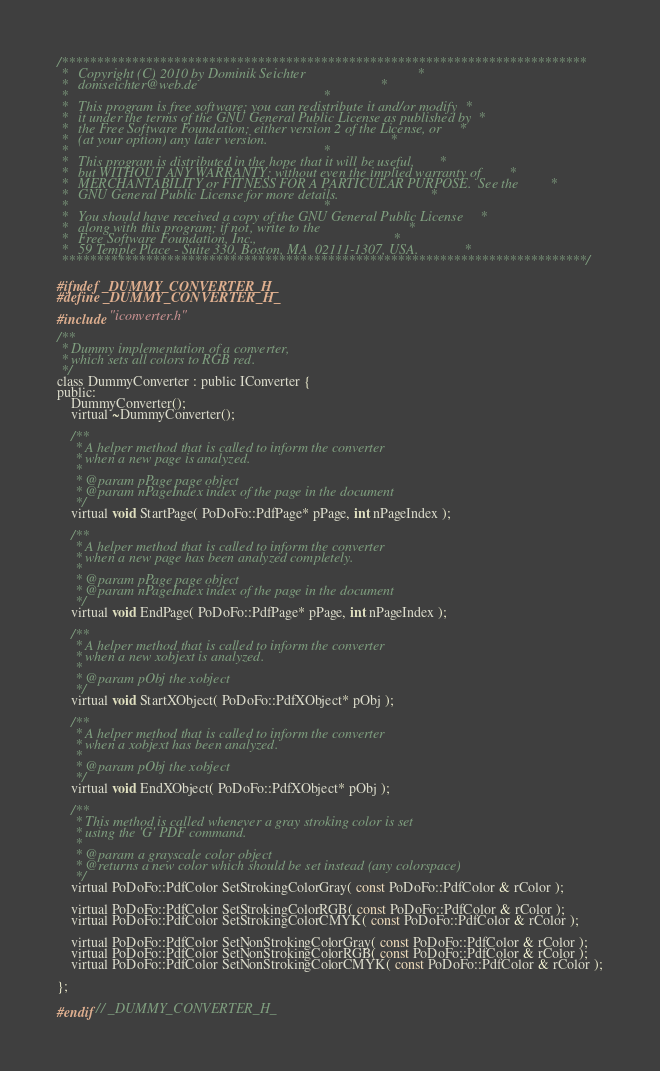<code> <loc_0><loc_0><loc_500><loc_500><_C_>/***************************************************************************
 *   Copyright (C) 2010 by Dominik Seichter                                *
 *   domseichter@web.de                                                    *
 *                                                                         *
 *   This program is free software; you can redistribute it and/or modify  *
 *   it under the terms of the GNU General Public License as published by  *
 *   the Free Software Foundation; either version 2 of the License, or     *
 *   (at your option) any later version.                                   *
 *                                                                         *
 *   This program is distributed in the hope that it will be useful,       *
 *   but WITHOUT ANY WARRANTY; without even the implied warranty of        *
 *   MERCHANTABILITY or FITNESS FOR A PARTICULAR PURPOSE.  See the         *
 *   GNU General Public License for more details.                          *
 *                                                                         *
 *   You should have received a copy of the GNU General Public License     *
 *   along with this program; if not, write to the                         *
 *   Free Software Foundation, Inc.,                                       *
 *   59 Temple Place - Suite 330, Boston, MA  02111-1307, USA.             *
 ***************************************************************************/

#ifndef _DUMMY_CONVERTER_H_
#define _DUMMY_CONVERTER_H_

#include "iconverter.h"

/**
 * Dummy implementation of a converter,
 * which sets all colors to RGB red.
 */
class DummyConverter : public IConverter {
public:
    DummyConverter();
    virtual ~DummyConverter();

    /**
     * A helper method that is called to inform the converter
     * when a new page is analyzed.
     * 
     * @param pPage page object
     * @param nPageIndex index of the page in the document
     */
    virtual void StartPage( PoDoFo::PdfPage* pPage, int nPageIndex );

    /**
     * A helper method that is called to inform the converter
     * when a new page has been analyzed completely.
     * 
     * @param pPage page object
     * @param nPageIndex index of the page in the document
     */
    virtual void EndPage( PoDoFo::PdfPage* pPage, int nPageIndex );

    /**
     * A helper method that is called to inform the converter
     * when a new xobjext is analyzed.
     * 
     * @param pObj the xobject
     */
    virtual void StartXObject( PoDoFo::PdfXObject* pObj );

    /**
     * A helper method that is called to inform the converter
     * when a xobjext has been analyzed.
     * 
     * @param pObj the xobject
     */
    virtual void EndXObject( PoDoFo::PdfXObject* pObj );

    /**
     * This method is called whenever a gray stroking color is set
     * using the 'G' PDF command.
     *
     * @param a grayscale color object
     * @returns a new color which should be set instead (any colorspace)
     */
    virtual PoDoFo::PdfColor SetStrokingColorGray( const PoDoFo::PdfColor & rColor );

    virtual PoDoFo::PdfColor SetStrokingColorRGB( const PoDoFo::PdfColor & rColor );
    virtual PoDoFo::PdfColor SetStrokingColorCMYK( const PoDoFo::PdfColor & rColor );
  
    virtual PoDoFo::PdfColor SetNonStrokingColorGray( const PoDoFo::PdfColor & rColor );
    virtual PoDoFo::PdfColor SetNonStrokingColorRGB( const PoDoFo::PdfColor & rColor );
    virtual PoDoFo::PdfColor SetNonStrokingColorCMYK( const PoDoFo::PdfColor & rColor );
  
};

#endif // _DUMMY_CONVERTER_H_
</code> 